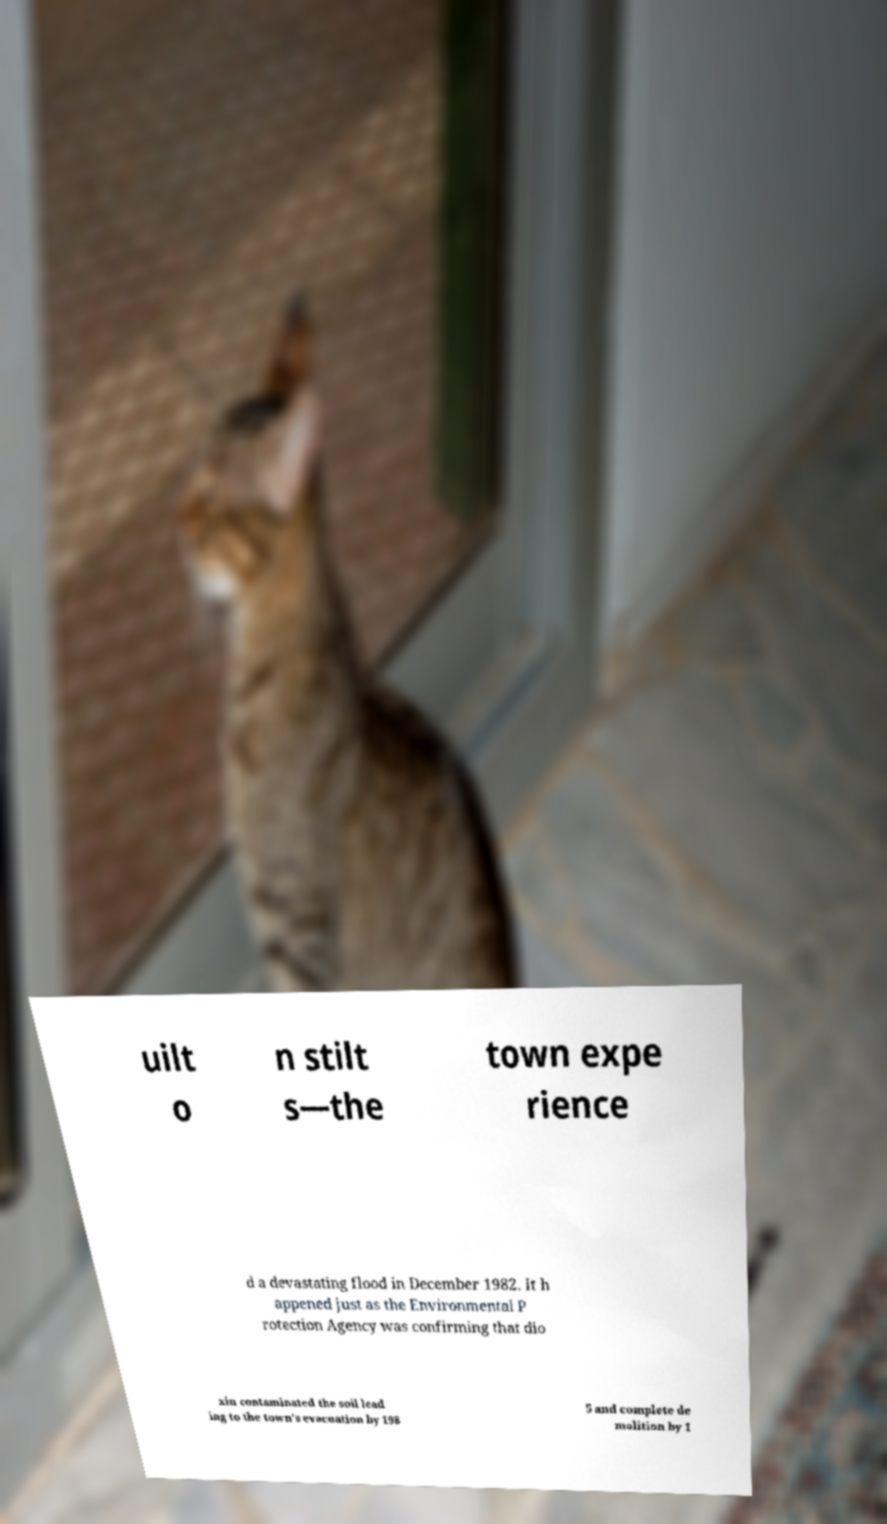I need the written content from this picture converted into text. Can you do that? uilt o n stilt s—the town expe rience d a devastating flood in December 1982. It h appened just as the Environmental P rotection Agency was confirming that dio xin contaminated the soil lead ing to the town's evacuation by 198 5 and complete de molition by 1 